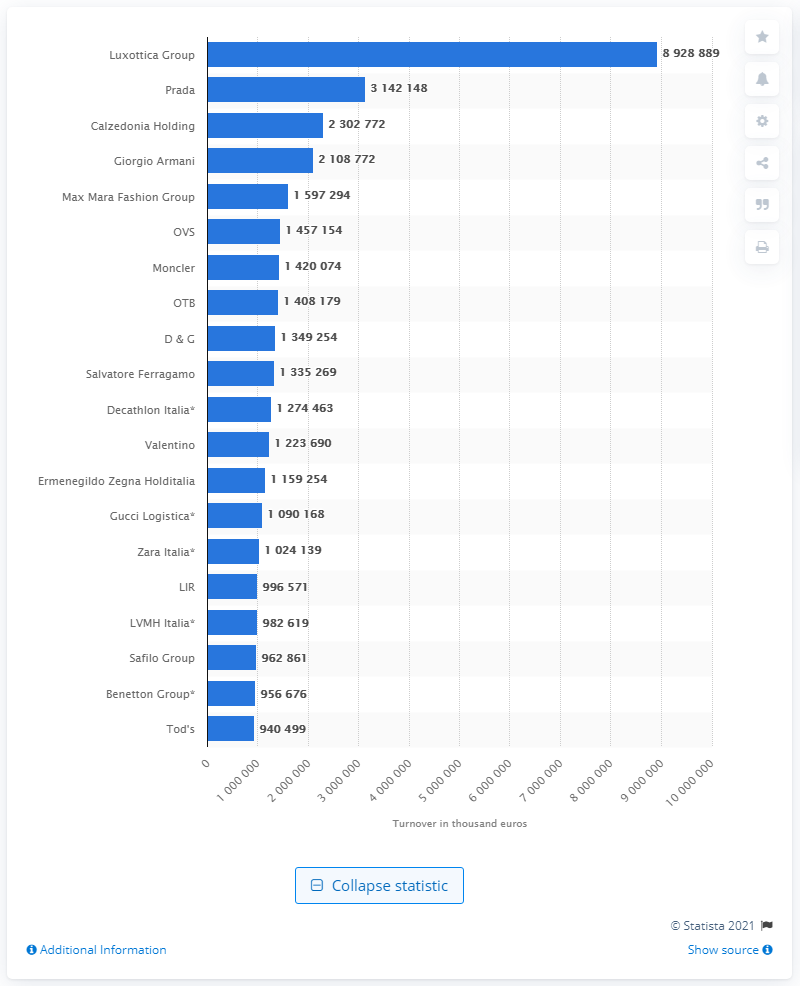List a handful of essential elements in this visual. Luxottica Group is the global leader in the eyewear sector and is an Italian fashion company. Prada, an Italian fashion company, ranked second in turnover in 2018. 